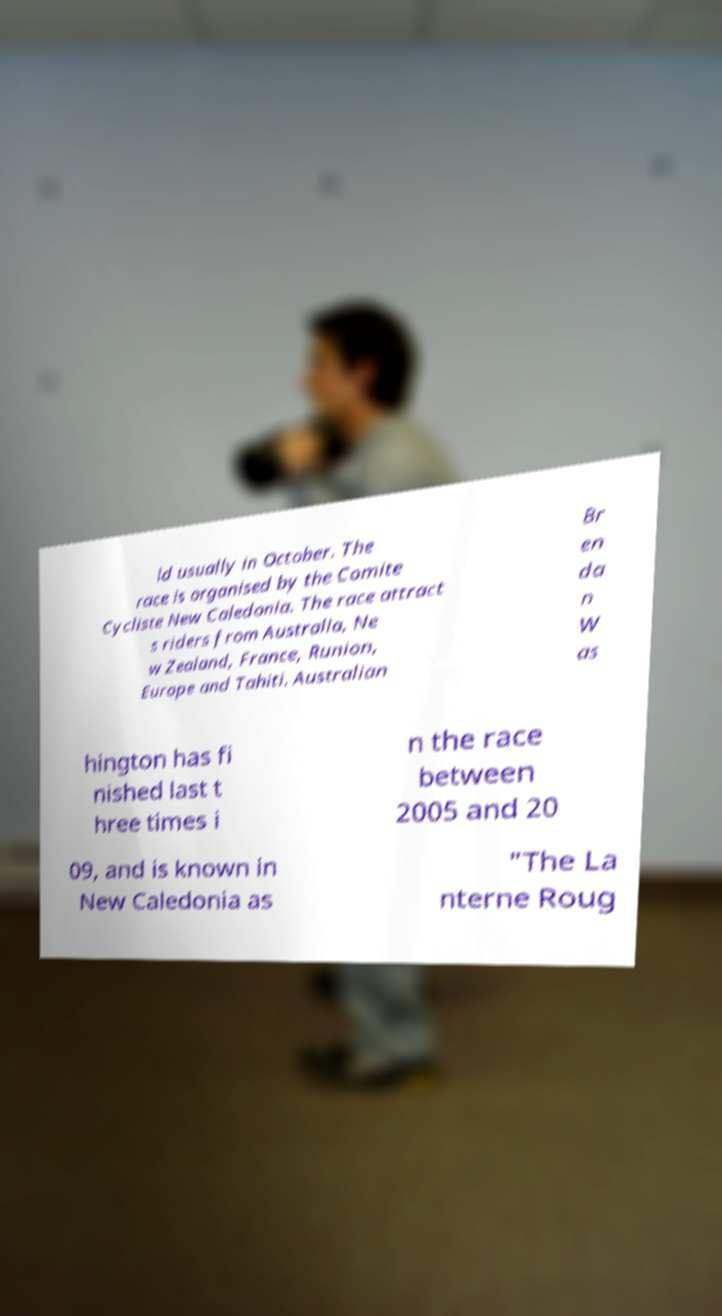What messages or text are displayed in this image? I need them in a readable, typed format. ld usually in October. The race is organised by the Comite Cycliste New Caledonia. The race attract s riders from Australia, Ne w Zealand, France, Runion, Europe and Tahiti. Australian Br en da n W as hington has fi nished last t hree times i n the race between 2005 and 20 09, and is known in New Caledonia as "The La nterne Roug 